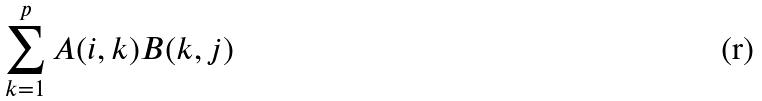<formula> <loc_0><loc_0><loc_500><loc_500>\sum _ { k = 1 } ^ { p } A ( i , k ) B ( k , j )</formula> 